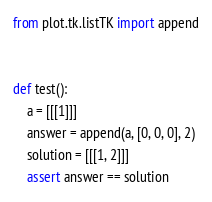Convert code to text. <code><loc_0><loc_0><loc_500><loc_500><_Python_>from plot.tk.listTK import append


def test():
    a = [[[1]]]
    answer = append(a, [0, 0, 0], 2)
    solution = [[[1, 2]]]
    assert answer == solution
</code> 